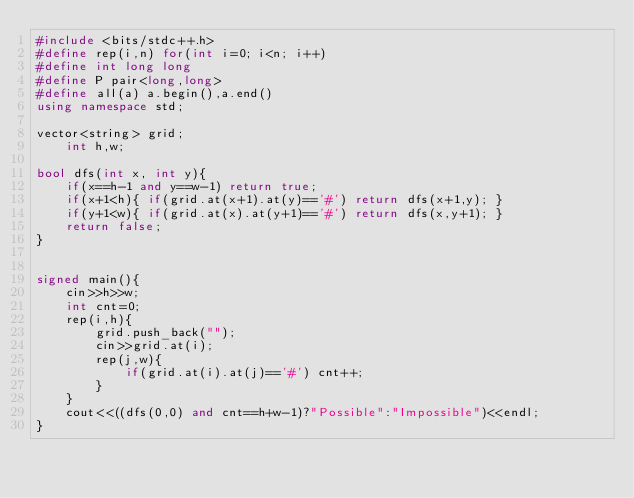Convert code to text. <code><loc_0><loc_0><loc_500><loc_500><_C++_>#include <bits/stdc++.h>
#define rep(i,n) for(int i=0; i<n; i++)
#define int long long
#define P pair<long,long>
#define all(a) a.begin(),a.end()
using namespace std;

vector<string> grid;
    int h,w;

bool dfs(int x, int y){
    if(x==h-1 and y==w-1) return true;
    if(x+1<h){ if(grid.at(x+1).at(y)=='#') return dfs(x+1,y); }
    if(y+1<w){ if(grid.at(x).at(y+1)=='#') return dfs(x,y+1); }
    return false;
}


signed main(){
    cin>>h>>w;
    int cnt=0;
    rep(i,h){
        grid.push_back("");
        cin>>grid.at(i);
        rep(j,w){
            if(grid.at(i).at(j)=='#') cnt++;
        }
    }
    cout<<((dfs(0,0) and cnt==h+w-1)?"Possible":"Impossible")<<endl;
}</code> 